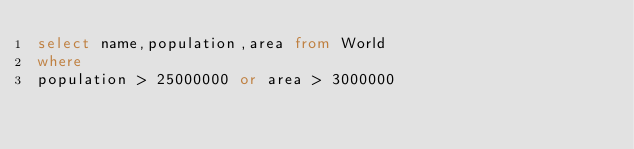Convert code to text. <code><loc_0><loc_0><loc_500><loc_500><_SQL_>select name,population,area from World
where
population > 25000000 or area > 3000000
</code> 